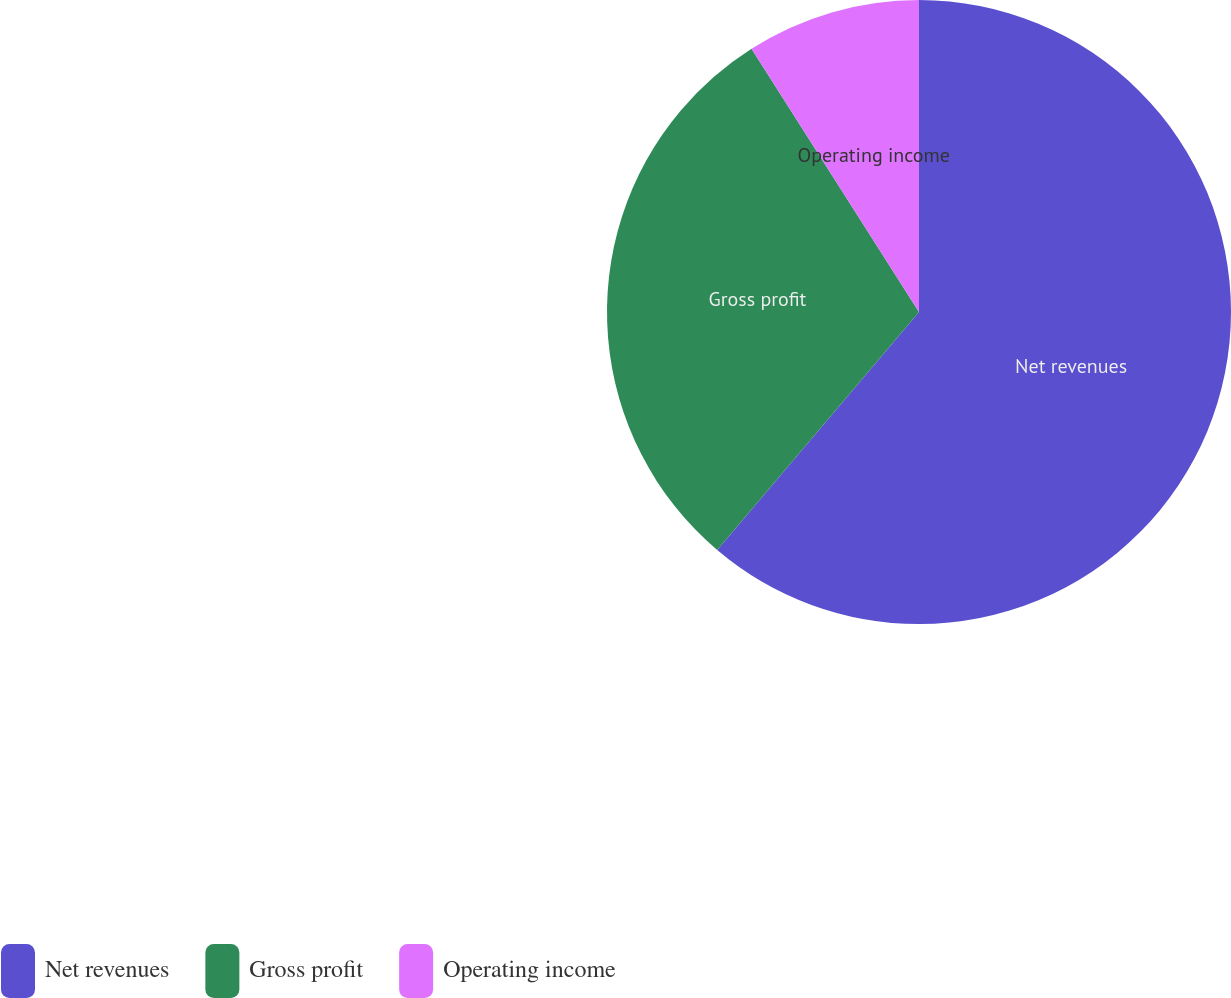<chart> <loc_0><loc_0><loc_500><loc_500><pie_chart><fcel>Net revenues<fcel>Gross profit<fcel>Operating income<nl><fcel>61.2%<fcel>29.79%<fcel>9.02%<nl></chart> 